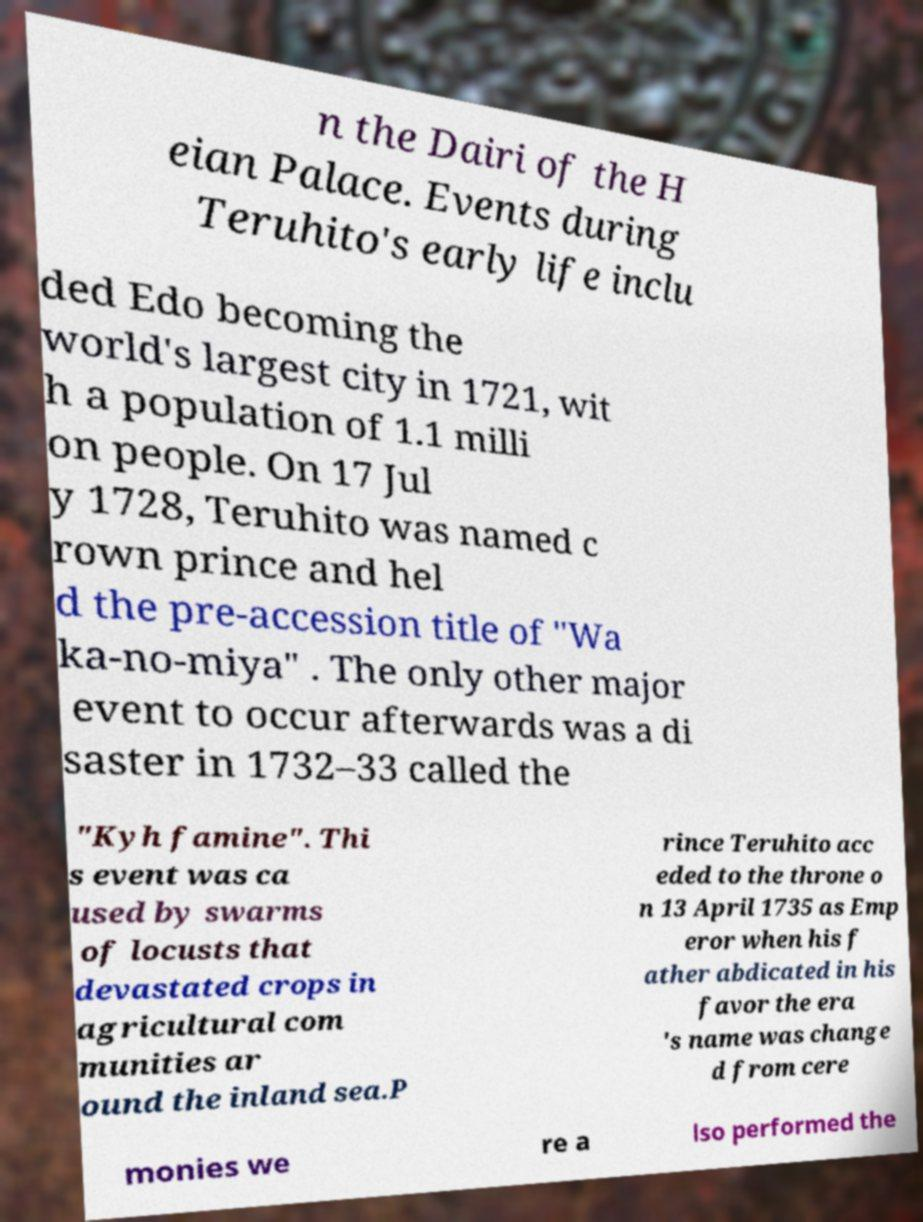Can you accurately transcribe the text from the provided image for me? n the Dairi of the H eian Palace. Events during Teruhito's early life inclu ded Edo becoming the world's largest city in 1721, wit h a population of 1.1 milli on people. On 17 Jul y 1728, Teruhito was named c rown prince and hel d the pre-accession title of "Wa ka-no-miya" . The only other major event to occur afterwards was a di saster in 1732–33 called the "Kyh famine". Thi s event was ca used by swarms of locusts that devastated crops in agricultural com munities ar ound the inland sea.P rince Teruhito acc eded to the throne o n 13 April 1735 as Emp eror when his f ather abdicated in his favor the era 's name was change d from cere monies we re a lso performed the 